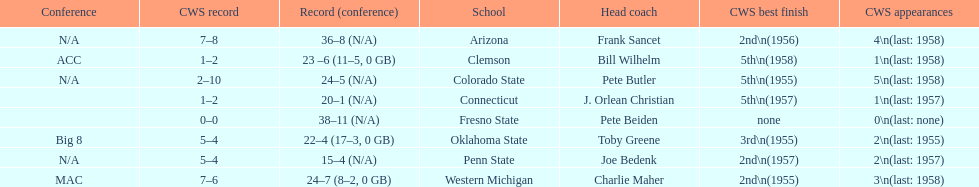Which school has no cws appearances? Fresno State. 